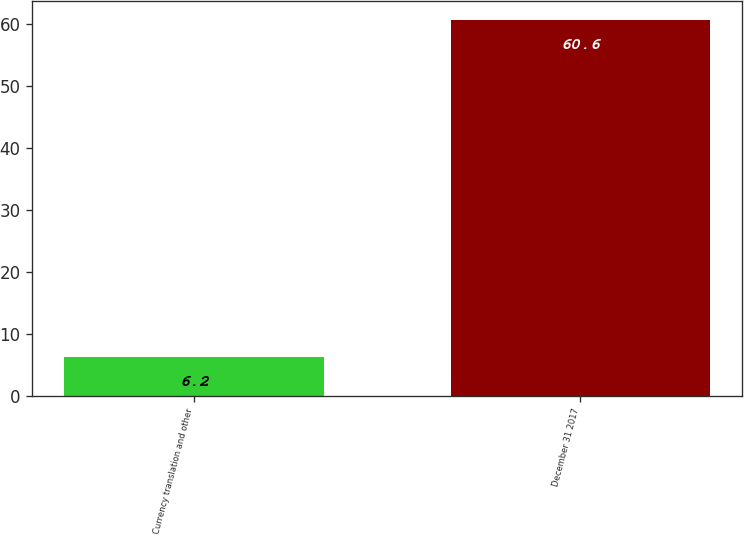Convert chart to OTSL. <chart><loc_0><loc_0><loc_500><loc_500><bar_chart><fcel>Currency translation and other<fcel>December 31 2017<nl><fcel>6.2<fcel>60.6<nl></chart> 